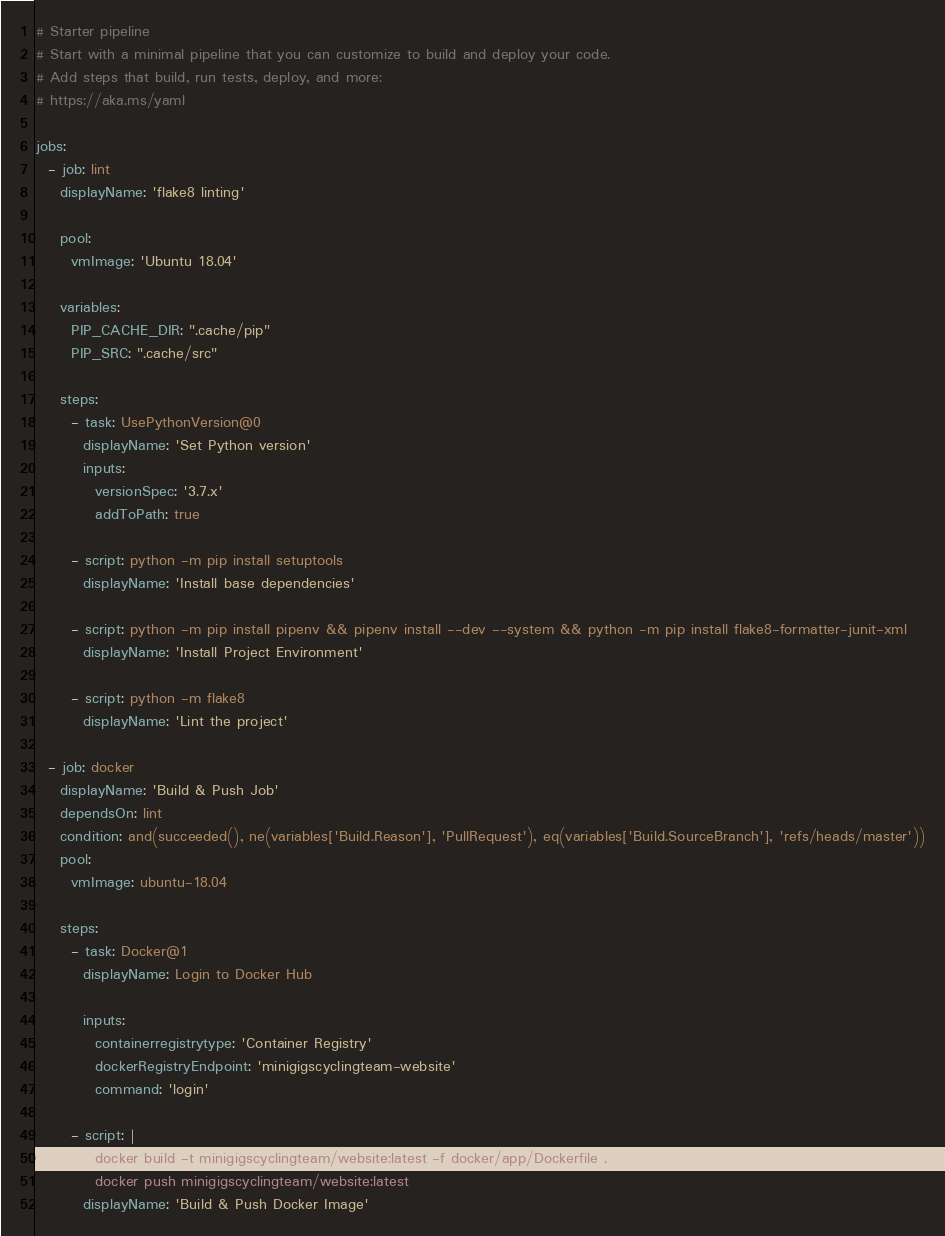<code> <loc_0><loc_0><loc_500><loc_500><_YAML_># Starter pipeline
# Start with a minimal pipeline that you can customize to build and deploy your code.
# Add steps that build, run tests, deploy, and more:
# https://aka.ms/yaml

jobs:
  - job: lint
    displayName: 'flake8 linting'

    pool:
      vmImage: 'Ubuntu 18.04'

    variables:
      PIP_CACHE_DIR: ".cache/pip"
      PIP_SRC: ".cache/src"

    steps:
      - task: UsePythonVersion@0
        displayName: 'Set Python version'
        inputs:
          versionSpec: '3.7.x'
          addToPath: true

      - script: python -m pip install setuptools
        displayName: 'Install base dependencies'

      - script: python -m pip install pipenv && pipenv install --dev --system && python -m pip install flake8-formatter-junit-xml
        displayName: 'Install Project Environment'

      - script: python -m flake8
        displayName: 'Lint the project'

  - job: docker
    displayName: 'Build & Push Job'
    dependsOn: lint
    condition: and(succeeded(), ne(variables['Build.Reason'], 'PullRequest'), eq(variables['Build.SourceBranch'], 'refs/heads/master'))
    pool:
      vmImage: ubuntu-18.04

    steps:
      - task: Docker@1
        displayName: Login to Docker Hub

        inputs:
          containerregistrytype: 'Container Registry'
          dockerRegistryEndpoint: 'minigigscyclingteam-website'
          command: 'login'

      - script: |
          docker build -t minigigscyclingteam/website:latest -f docker/app/Dockerfile .
          docker push minigigscyclingteam/website:latest
        displayName: 'Build & Push Docker Image'
</code> 